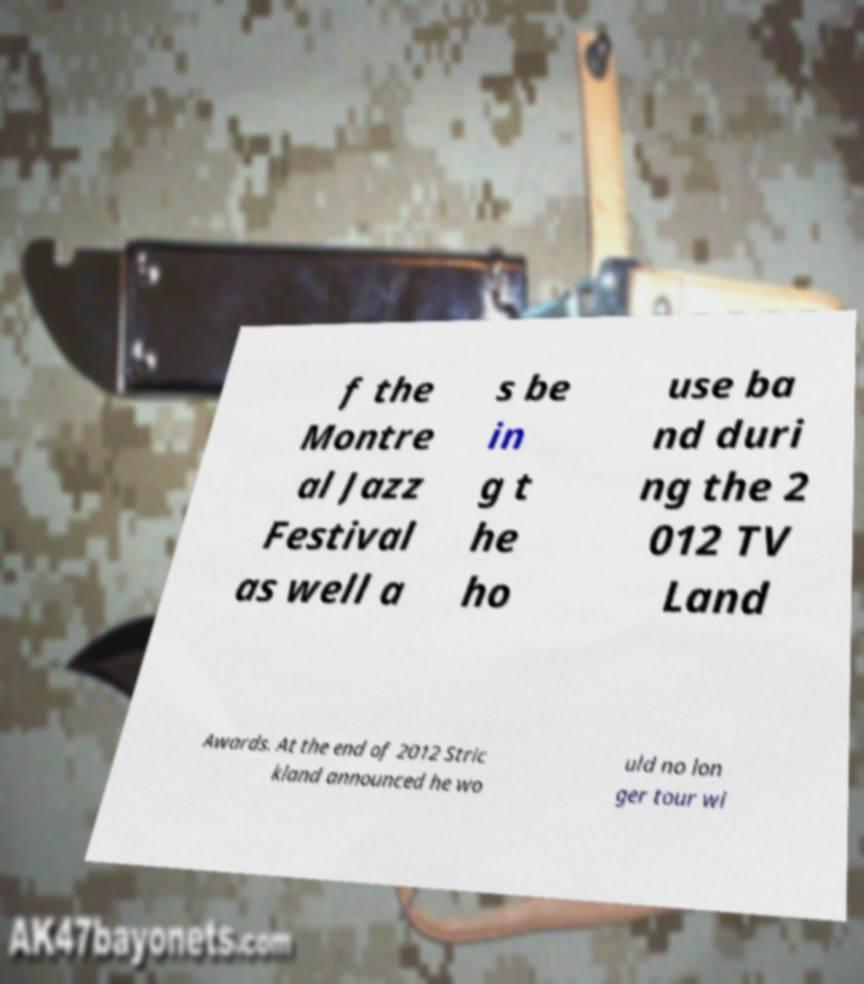Please read and relay the text visible in this image. What does it say? f the Montre al Jazz Festival as well a s be in g t he ho use ba nd duri ng the 2 012 TV Land Awards. At the end of 2012 Stric kland announced he wo uld no lon ger tour wi 